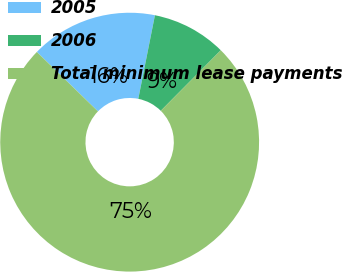<chart> <loc_0><loc_0><loc_500><loc_500><pie_chart><fcel>2005<fcel>2006<fcel>Total minimum lease payments<nl><fcel>15.86%<fcel>9.31%<fcel>74.84%<nl></chart> 